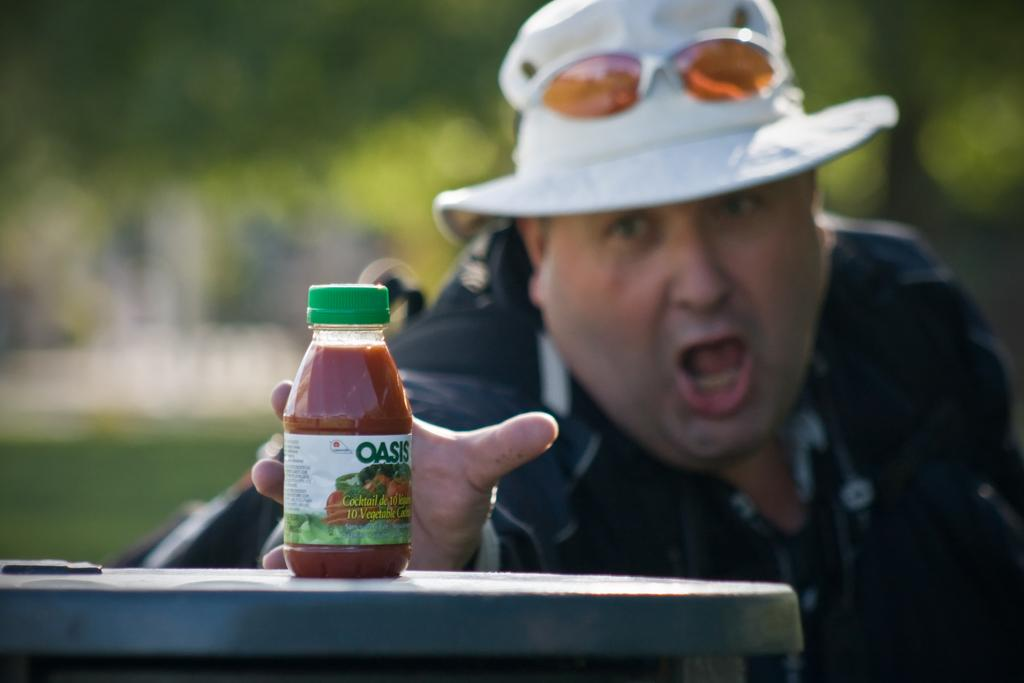What is the person wearing on their head in the image? The person is wearing a cap in the image. What type of eyewear is the person wearing? The person is wearing spectacles in the image. What is the person holding in the image? The person is holding a bottle in the image. What piece of furniture is present in the image? There is a table in the image. Where is the bottle placed in the image? The bottle is on the table in the image. What can be seen in the distance in the image? There are trees visible in the background of the image. How many ladybugs are crawling on the person's cap in the image? There are no ladybugs visible on the person's cap in the image. What type of lizards can be seen basking on the table in the image? There are no lizards present in the image; the person is holding a bottle on the table. 